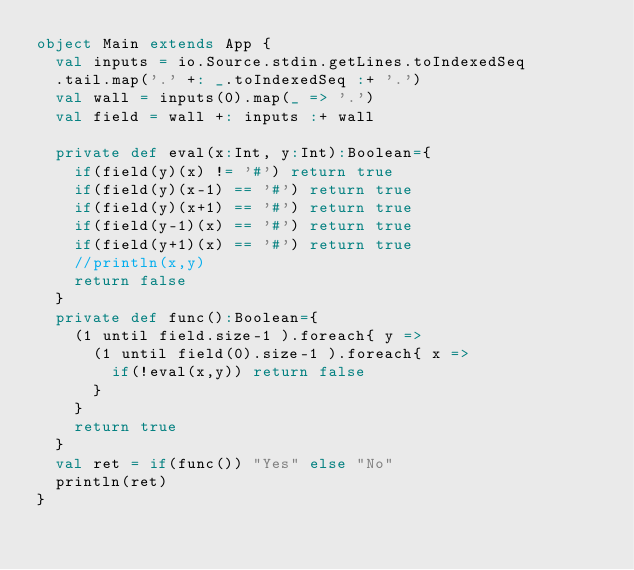<code> <loc_0><loc_0><loc_500><loc_500><_Scala_>object Main extends App {
  val inputs = io.Source.stdin.getLines.toIndexedSeq
  .tail.map('.' +: _.toIndexedSeq :+ '.')
  val wall = inputs(0).map(_ => '.')
  val field = wall +: inputs :+ wall
  
  private def eval(x:Int, y:Int):Boolean={
    if(field(y)(x) != '#') return true
    if(field(y)(x-1) == '#') return true
    if(field(y)(x+1) == '#') return true
    if(field(y-1)(x) == '#') return true
    if(field(y+1)(x) == '#') return true
    //println(x,y)
    return false
  }
  private def func():Boolean={
    (1 until field.size-1 ).foreach{ y =>
      (1 until field(0).size-1 ).foreach{ x =>
        if(!eval(x,y)) return false
      }
    }
    return true
  }
  val ret = if(func()) "Yes" else "No"
  println(ret)
}
</code> 